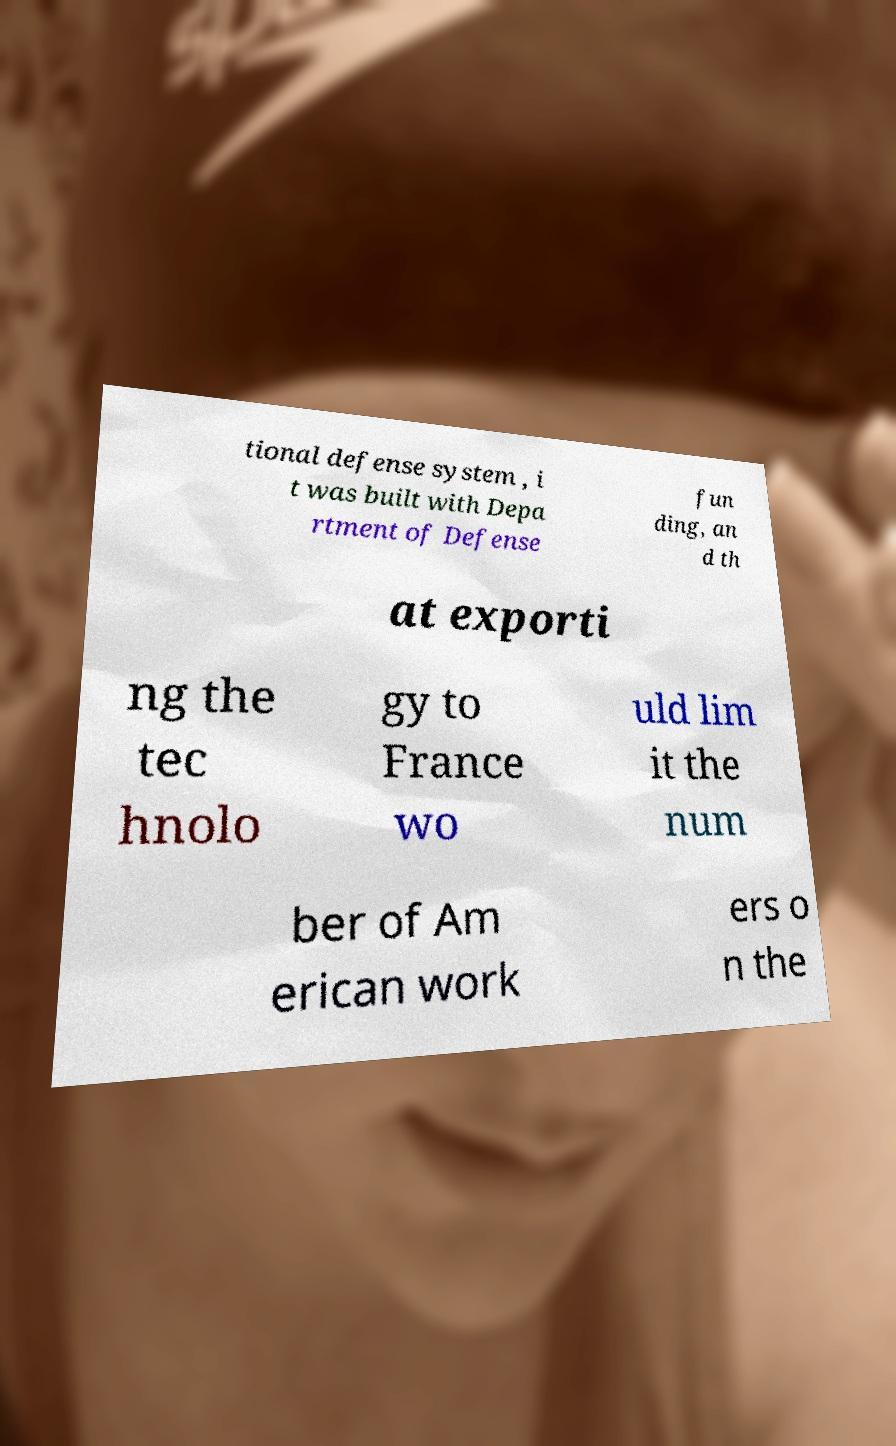There's text embedded in this image that I need extracted. Can you transcribe it verbatim? tional defense system , i t was built with Depa rtment of Defense fun ding, an d th at exporti ng the tec hnolo gy to France wo uld lim it the num ber of Am erican work ers o n the 